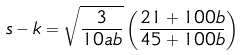Convert formula to latex. <formula><loc_0><loc_0><loc_500><loc_500>s - k = \sqrt { \frac { 3 } { 1 0 a b } } \left ( \frac { 2 1 + 1 0 0 b } { 4 5 + 1 0 0 b } \right )</formula> 